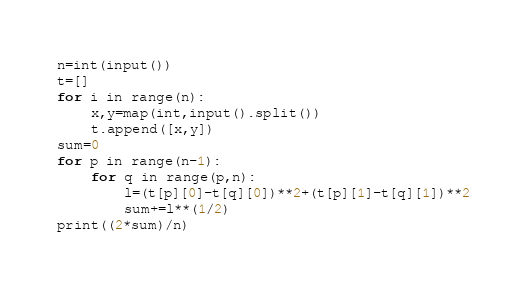<code> <loc_0><loc_0><loc_500><loc_500><_Python_>n=int(input())
t=[]
for i in range(n):
    x,y=map(int,input().split())
    t.append([x,y])
sum=0
for p in range(n-1):
    for q in range(p,n):
        l=(t[p][0]-t[q][0])**2+(t[p][1]-t[q][1])**2
        sum+=l**(1/2)
print((2*sum)/n)
</code> 